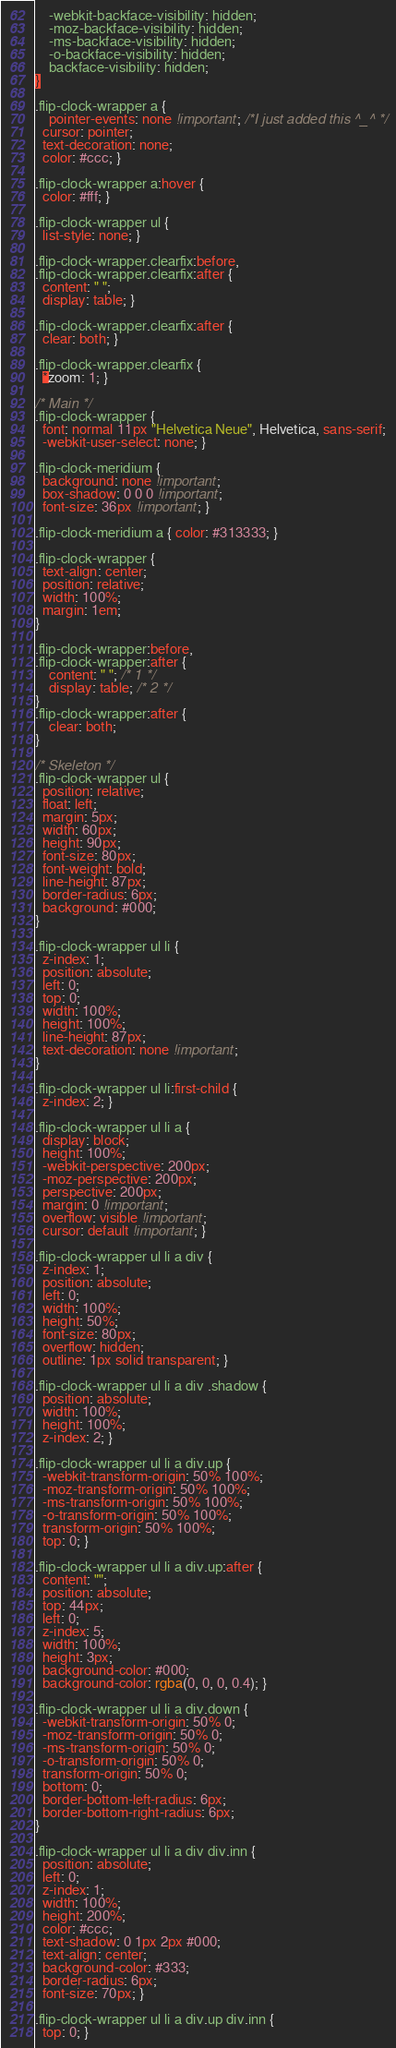<code> <loc_0><loc_0><loc_500><loc_500><_CSS_>    -webkit-backface-visibility: hidden;
    -moz-backface-visibility: hidden;
    -ms-backface-visibility: hidden;
    -o-backface-visibility: hidden;
    backface-visibility: hidden;
}

.flip-clock-wrapper a {
    pointer-events: none !important; /*I just added this ^_^ */
  cursor: pointer;
  text-decoration: none;
  color: #ccc; }

.flip-clock-wrapper a:hover {
  color: #fff; }

.flip-clock-wrapper ul {
  list-style: none; }

.flip-clock-wrapper.clearfix:before,
.flip-clock-wrapper.clearfix:after {
  content: " ";
  display: table; }

.flip-clock-wrapper.clearfix:after {
  clear: both; }

.flip-clock-wrapper.clearfix {
  *zoom: 1; }

/* Main */
.flip-clock-wrapper {
  font: normal 11px "Helvetica Neue", Helvetica, sans-serif;
  -webkit-user-select: none; }

.flip-clock-meridium {
  background: none !important;
  box-shadow: 0 0 0 !important;
  font-size: 36px !important; }

.flip-clock-meridium a { color: #313333; }

.flip-clock-wrapper {
  text-align: center;
  position: relative;
  width: 100%;
  margin: 1em;
}

.flip-clock-wrapper:before,
.flip-clock-wrapper:after {
    content: " "; /* 1 */
    display: table; /* 2 */
}
.flip-clock-wrapper:after {
    clear: both;
}

/* Skeleton */
.flip-clock-wrapper ul {
  position: relative;
  float: left;
  margin: 5px;
  width: 60px;
  height: 90px;
  font-size: 80px;
  font-weight: bold;
  line-height: 87px;
  border-radius: 6px;
  background: #000;
}

.flip-clock-wrapper ul li {
  z-index: 1;
  position: absolute;
  left: 0;
  top: 0;
  width: 100%;
  height: 100%;
  line-height: 87px;
  text-decoration: none !important;
}

.flip-clock-wrapper ul li:first-child {
  z-index: 2; }

.flip-clock-wrapper ul li a {
  display: block;
  height: 100%;
  -webkit-perspective: 200px;
  -moz-perspective: 200px;
  perspective: 200px;
  margin: 0 !important;
  overflow: visible !important;
  cursor: default !important; }

.flip-clock-wrapper ul li a div {
  z-index: 1;
  position: absolute;
  left: 0;
  width: 100%;
  height: 50%;
  font-size: 80px;
  overflow: hidden;
  outline: 1px solid transparent; }

.flip-clock-wrapper ul li a div .shadow {
  position: absolute;
  width: 100%;
  height: 100%;
  z-index: 2; }

.flip-clock-wrapper ul li a div.up {
  -webkit-transform-origin: 50% 100%;
  -moz-transform-origin: 50% 100%;
  -ms-transform-origin: 50% 100%;
  -o-transform-origin: 50% 100%;
  transform-origin: 50% 100%;
  top: 0; }

.flip-clock-wrapper ul li a div.up:after {
  content: "";
  position: absolute;
  top: 44px;
  left: 0;
  z-index: 5;
  width: 100%;
  height: 3px;
  background-color: #000;
  background-color: rgba(0, 0, 0, 0.4); }

.flip-clock-wrapper ul li a div.down {
  -webkit-transform-origin: 50% 0;
  -moz-transform-origin: 50% 0;
  -ms-transform-origin: 50% 0;
  -o-transform-origin: 50% 0;
  transform-origin: 50% 0;
  bottom: 0;
  border-bottom-left-radius: 6px;
  border-bottom-right-radius: 6px;
}

.flip-clock-wrapper ul li a div div.inn {
  position: absolute;
  left: 0;
  z-index: 1;
  width: 100%;
  height: 200%;
  color: #ccc;
  text-shadow: 0 1px 2px #000;
  text-align: center;
  background-color: #333;
  border-radius: 6px;
  font-size: 70px; }

.flip-clock-wrapper ul li a div.up div.inn {
  top: 0; }
</code> 